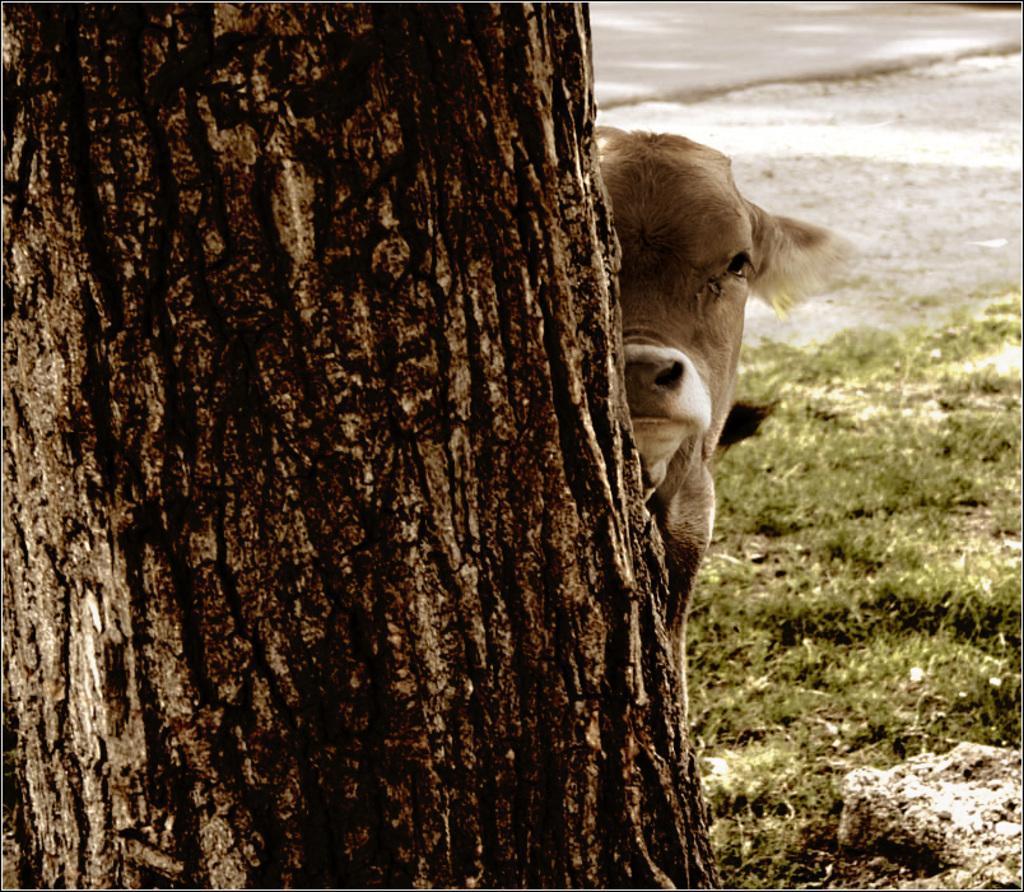Describe this image in one or two sentences. In this image we can see the bark of a tree, animal and also the grass. In the background we can see the road and also the path. 